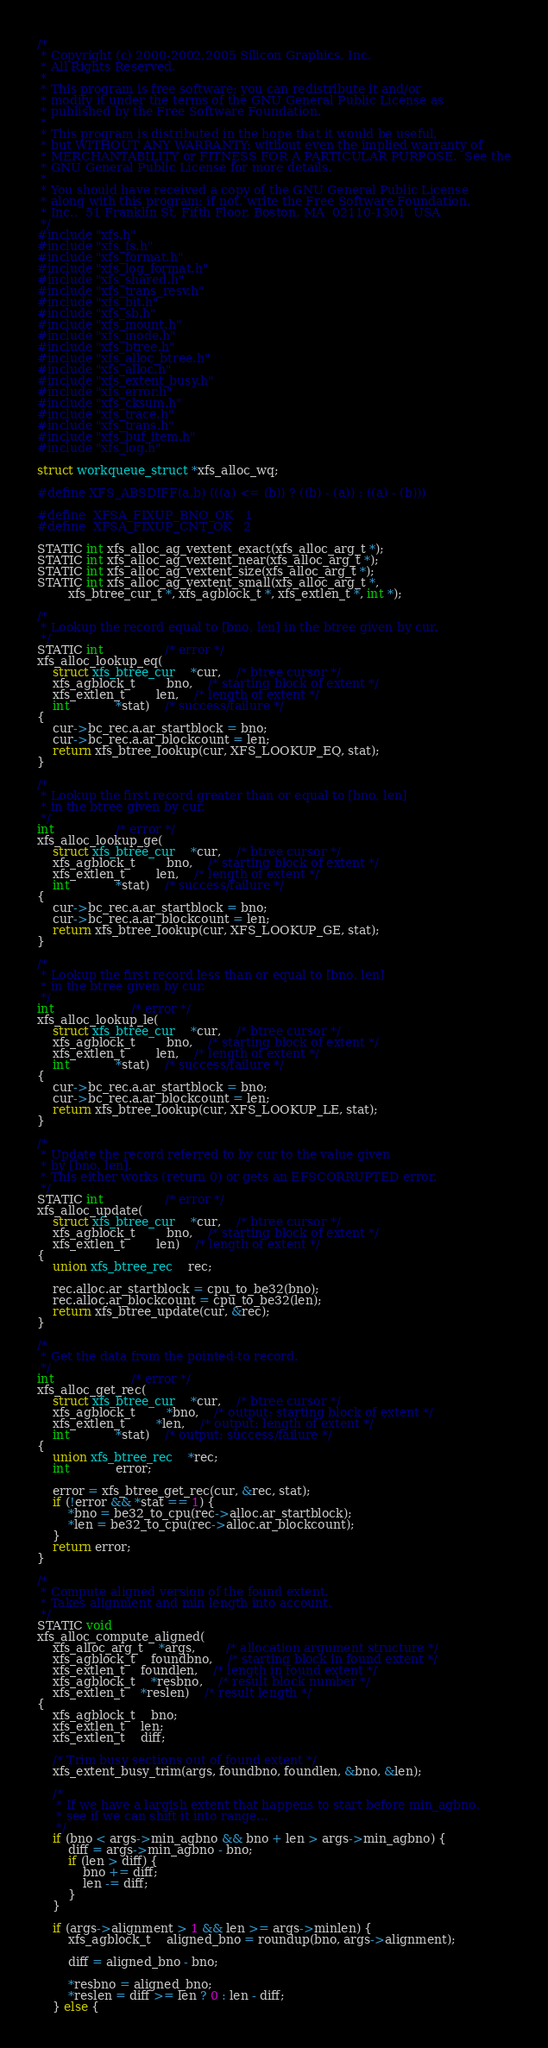Convert code to text. <code><loc_0><loc_0><loc_500><loc_500><_C_>/*
 * Copyright (c) 2000-2002,2005 Silicon Graphics, Inc.
 * All Rights Reserved.
 *
 * This program is free software; you can redistribute it and/or
 * modify it under the terms of the GNU General Public License as
 * published by the Free Software Foundation.
 *
 * This program is distributed in the hope that it would be useful,
 * but WITHOUT ANY WARRANTY; without even the implied warranty of
 * MERCHANTABILITY or FITNESS FOR A PARTICULAR PURPOSE.  See the
 * GNU General Public License for more details.
 *
 * You should have received a copy of the GNU General Public License
 * along with this program; if not, write the Free Software Foundation,
 * Inc.,  51 Franklin St, Fifth Floor, Boston, MA  02110-1301  USA
 */
#include "xfs.h"
#include "xfs_fs.h"
#include "xfs_format.h"
#include "xfs_log_format.h"
#include "xfs_shared.h"
#include "xfs_trans_resv.h"
#include "xfs_bit.h"
#include "xfs_sb.h"
#include "xfs_mount.h"
#include "xfs_inode.h"
#include "xfs_btree.h"
#include "xfs_alloc_btree.h"
#include "xfs_alloc.h"
#include "xfs_extent_busy.h"
#include "xfs_error.h"
#include "xfs_cksum.h"
#include "xfs_trace.h"
#include "xfs_trans.h"
#include "xfs_buf_item.h"
#include "xfs_log.h"

struct workqueue_struct *xfs_alloc_wq;

#define XFS_ABSDIFF(a,b)	(((a) <= (b)) ? ((b) - (a)) : ((a) - (b)))

#define	XFSA_FIXUP_BNO_OK	1
#define	XFSA_FIXUP_CNT_OK	2

STATIC int xfs_alloc_ag_vextent_exact(xfs_alloc_arg_t *);
STATIC int xfs_alloc_ag_vextent_near(xfs_alloc_arg_t *);
STATIC int xfs_alloc_ag_vextent_size(xfs_alloc_arg_t *);
STATIC int xfs_alloc_ag_vextent_small(xfs_alloc_arg_t *,
		xfs_btree_cur_t *, xfs_agblock_t *, xfs_extlen_t *, int *);

/*
 * Lookup the record equal to [bno, len] in the btree given by cur.
 */
STATIC int				/* error */
xfs_alloc_lookup_eq(
	struct xfs_btree_cur	*cur,	/* btree cursor */
	xfs_agblock_t		bno,	/* starting block of extent */
	xfs_extlen_t		len,	/* length of extent */
	int			*stat)	/* success/failure */
{
	cur->bc_rec.a.ar_startblock = bno;
	cur->bc_rec.a.ar_blockcount = len;
	return xfs_btree_lookup(cur, XFS_LOOKUP_EQ, stat);
}

/*
 * Lookup the first record greater than or equal to [bno, len]
 * in the btree given by cur.
 */
int				/* error */
xfs_alloc_lookup_ge(
	struct xfs_btree_cur	*cur,	/* btree cursor */
	xfs_agblock_t		bno,	/* starting block of extent */
	xfs_extlen_t		len,	/* length of extent */
	int			*stat)	/* success/failure */
{
	cur->bc_rec.a.ar_startblock = bno;
	cur->bc_rec.a.ar_blockcount = len;
	return xfs_btree_lookup(cur, XFS_LOOKUP_GE, stat);
}

/*
 * Lookup the first record less than or equal to [bno, len]
 * in the btree given by cur.
 */
int					/* error */
xfs_alloc_lookup_le(
	struct xfs_btree_cur	*cur,	/* btree cursor */
	xfs_agblock_t		bno,	/* starting block of extent */
	xfs_extlen_t		len,	/* length of extent */
	int			*stat)	/* success/failure */
{
	cur->bc_rec.a.ar_startblock = bno;
	cur->bc_rec.a.ar_blockcount = len;
	return xfs_btree_lookup(cur, XFS_LOOKUP_LE, stat);
}

/*
 * Update the record referred to by cur to the value given
 * by [bno, len].
 * This either works (return 0) or gets an EFSCORRUPTED error.
 */
STATIC int				/* error */
xfs_alloc_update(
	struct xfs_btree_cur	*cur,	/* btree cursor */
	xfs_agblock_t		bno,	/* starting block of extent */
	xfs_extlen_t		len)	/* length of extent */
{
	union xfs_btree_rec	rec;

	rec.alloc.ar_startblock = cpu_to_be32(bno);
	rec.alloc.ar_blockcount = cpu_to_be32(len);
	return xfs_btree_update(cur, &rec);
}

/*
 * Get the data from the pointed-to record.
 */
int					/* error */
xfs_alloc_get_rec(
	struct xfs_btree_cur	*cur,	/* btree cursor */
	xfs_agblock_t		*bno,	/* output: starting block of extent */
	xfs_extlen_t		*len,	/* output: length of extent */
	int			*stat)	/* output: success/failure */
{
	union xfs_btree_rec	*rec;
	int			error;

	error = xfs_btree_get_rec(cur, &rec, stat);
	if (!error && *stat == 1) {
		*bno = be32_to_cpu(rec->alloc.ar_startblock);
		*len = be32_to_cpu(rec->alloc.ar_blockcount);
	}
	return error;
}

/*
 * Compute aligned version of the found extent.
 * Takes alignment and min length into account.
 */
STATIC void
xfs_alloc_compute_aligned(
	xfs_alloc_arg_t	*args,		/* allocation argument structure */
	xfs_agblock_t	foundbno,	/* starting block in found extent */
	xfs_extlen_t	foundlen,	/* length in found extent */
	xfs_agblock_t	*resbno,	/* result block number */
	xfs_extlen_t	*reslen)	/* result length */
{
	xfs_agblock_t	bno;
	xfs_extlen_t	len;
	xfs_extlen_t	diff;

	/* Trim busy sections out of found extent */
	xfs_extent_busy_trim(args, foundbno, foundlen, &bno, &len);

	/*
	 * If we have a largish extent that happens to start before min_agbno,
	 * see if we can shift it into range...
	 */
	if (bno < args->min_agbno && bno + len > args->min_agbno) {
		diff = args->min_agbno - bno;
		if (len > diff) {
			bno += diff;
			len -= diff;
		}
	}

	if (args->alignment > 1 && len >= args->minlen) {
		xfs_agblock_t	aligned_bno = roundup(bno, args->alignment);

		diff = aligned_bno - bno;

		*resbno = aligned_bno;
		*reslen = diff >= len ? 0 : len - diff;
	} else {</code> 